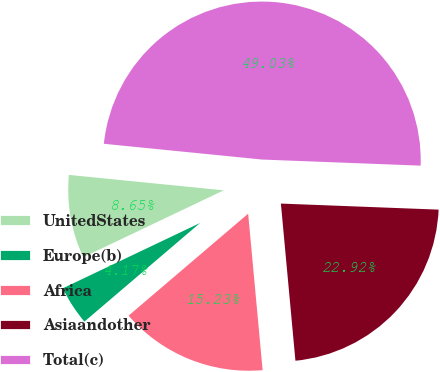<chart> <loc_0><loc_0><loc_500><loc_500><pie_chart><fcel>UnitedStates<fcel>Europe(b)<fcel>Africa<fcel>Asiaandother<fcel>Total(c)<nl><fcel>8.65%<fcel>4.17%<fcel>15.23%<fcel>22.92%<fcel>49.03%<nl></chart> 